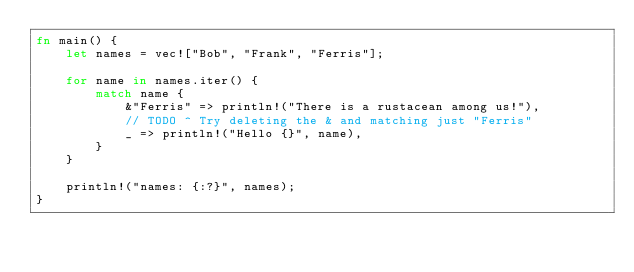Convert code to text. <code><loc_0><loc_0><loc_500><loc_500><_Rust_>fn main() {
    let names = vec!["Bob", "Frank", "Ferris"];

    for name in names.iter() {
        match name {
            &"Ferris" => println!("There is a rustacean among us!"),
            // TODO ^ Try deleting the & and matching just "Ferris"
            _ => println!("Hello {}", name),
        }
    }
    
    println!("names: {:?}", names);
}
</code> 